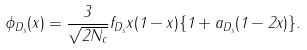<formula> <loc_0><loc_0><loc_500><loc_500>\phi _ { D _ { s } } ( x ) = \frac { 3 } { \sqrt { 2 N _ { c } } } f _ { D _ { s } } x ( 1 - x ) \{ 1 + a _ { D _ { s } } ( 1 - 2 x ) \} .</formula> 